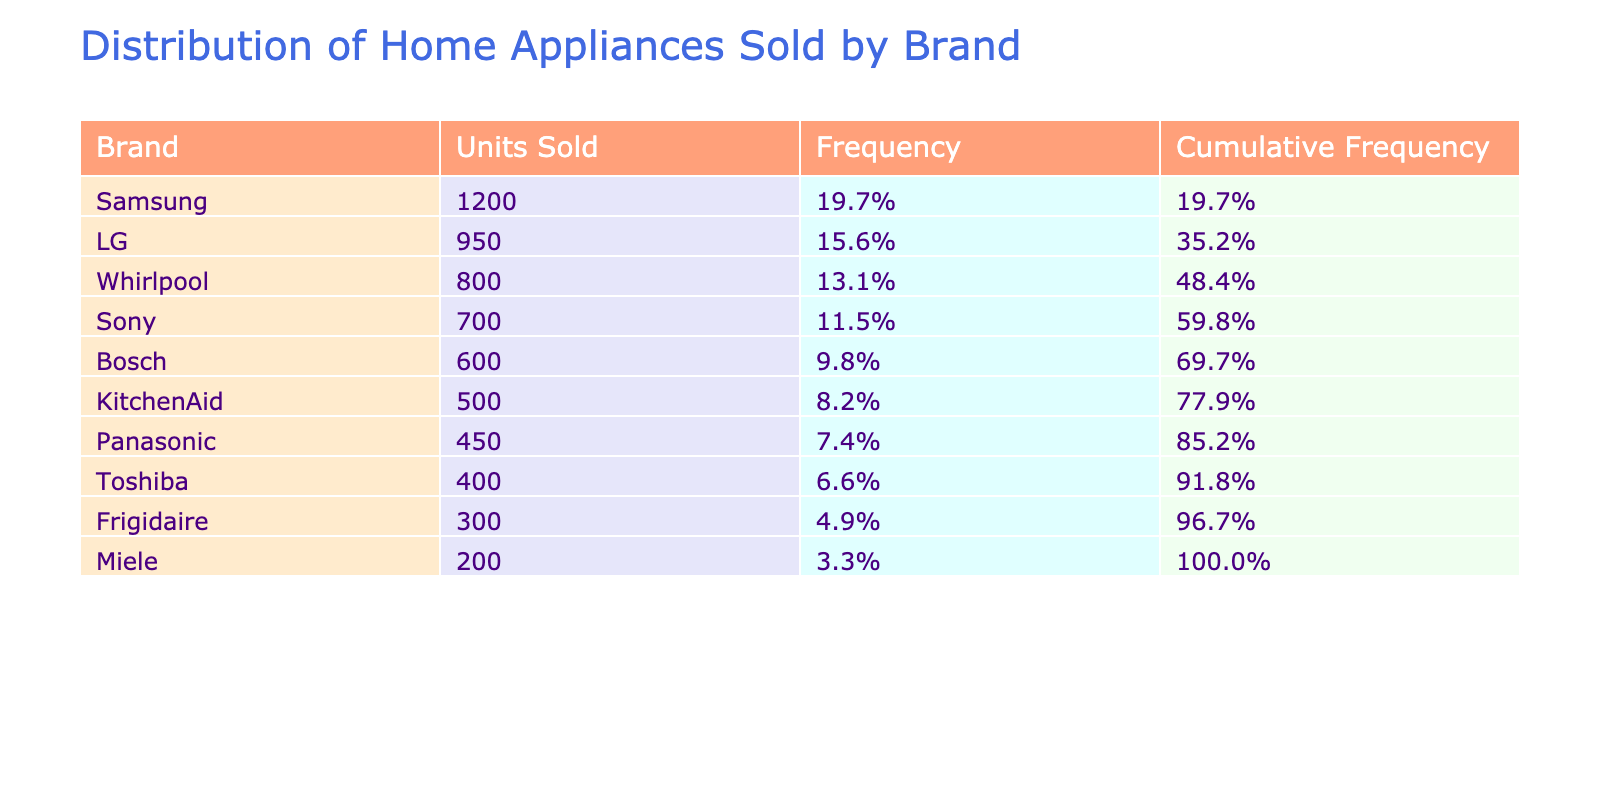What brand sold the most units? The question is asking for the brand that has the highest number of units sold. Looking at the "Units Sold" column, Samsung has the highest value at 1200 units.
Answer: Samsung What percentage of total units sold does LG represent? First, we find the total units sold by adding up all the units: 1200 + 950 + 800 + 500 + 600 + 700 + 450 + 300 + 400 + 200 = 5850. Now, to find the percentage of LG, we take the units sold by LG which is 950 and divide it by the total units (5850), then multiply by 100: (950 / 5850) * 100 = 16.2%.
Answer: 16.2% Is Miele's units sold less than 10% of total units sold? As previously calculated, the total units sold is 5850. Miele sold 200 units. To find out if it’s less than 10%, we can calculate 10% of total units: 0.10 * 5850 = 585. Since 200 is less than 585, the answer is yes.
Answer: Yes What is the cumulative frequency for Bosch? To find Bosch's cumulative frequency, we need to look at the frequencies of all brands sold before it in the sorted order. Based on operational logic: Samsung has a frequency of 20.5%, LG 16.2%, Whirlpool 13.6%, KitchenAid 8.5%, Bosche 10.3%. Summing these gives us: 20.5% + 16.2% + 13.6% + 8.5% = 68.8%. Adding Bosch's frequency (10.3%) gives a cumulative frequency of 79.1%.
Answer: 79.1% How many brands sold more than 600 units? Looking through the "Units Sold" column, we need to count the brands that have more than 600 units. The brands with more than 600 units are Samsung (1200), LG (950), and Whirlpool (800), making a total of three brands.
Answer: 3 